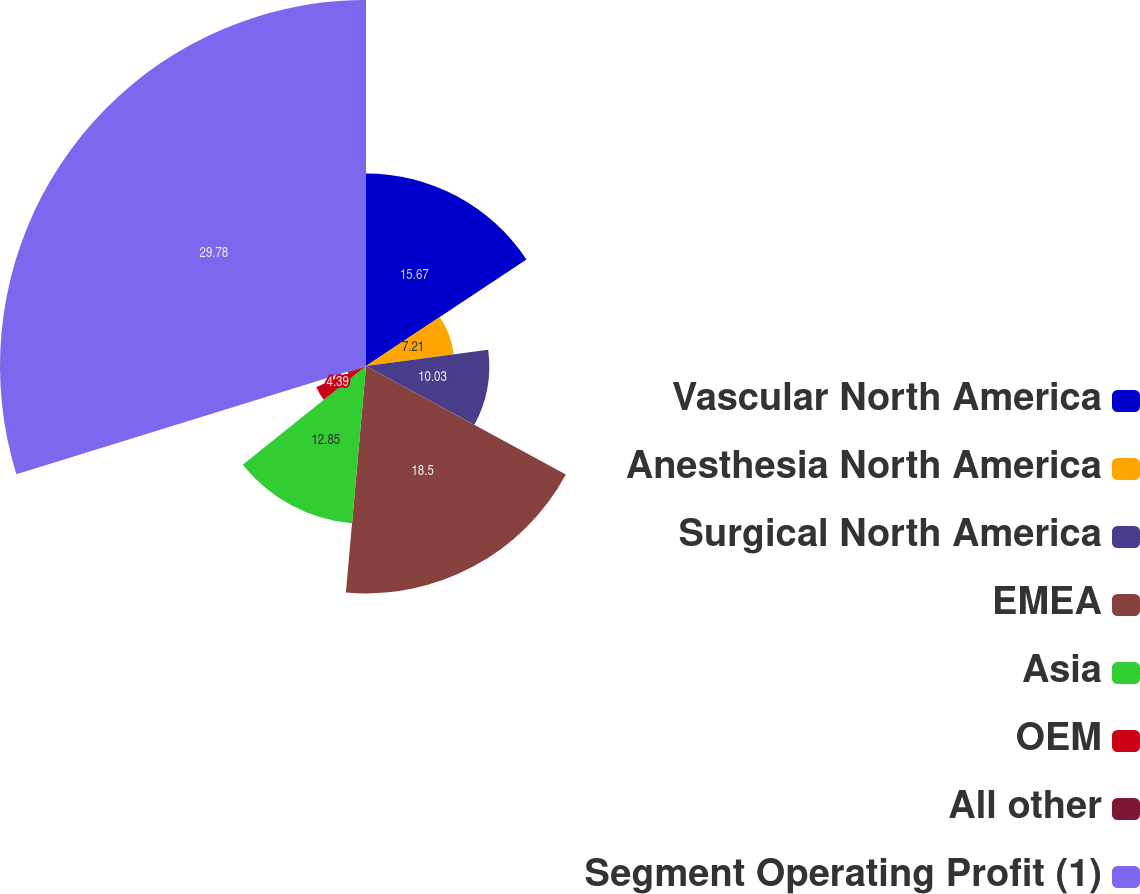Convert chart. <chart><loc_0><loc_0><loc_500><loc_500><pie_chart><fcel>Vascular North America<fcel>Anesthesia North America<fcel>Surgical North America<fcel>EMEA<fcel>Asia<fcel>OEM<fcel>All other<fcel>Segment Operating Profit (1)<nl><fcel>15.67%<fcel>7.21%<fcel>10.03%<fcel>18.5%<fcel>12.85%<fcel>4.39%<fcel>1.57%<fcel>29.78%<nl></chart> 